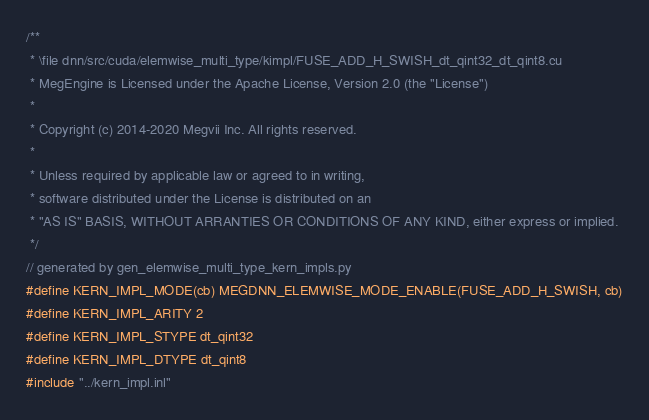<code> <loc_0><loc_0><loc_500><loc_500><_Cuda_>/**
 * \file dnn/src/cuda/elemwise_multi_type/kimpl/FUSE_ADD_H_SWISH_dt_qint32_dt_qint8.cu
 * MegEngine is Licensed under the Apache License, Version 2.0 (the "License")
 *
 * Copyright (c) 2014-2020 Megvii Inc. All rights reserved.
 *
 * Unless required by applicable law or agreed to in writing,
 * software distributed under the License is distributed on an
 * "AS IS" BASIS, WITHOUT ARRANTIES OR CONDITIONS OF ANY KIND, either express or implied.
 */
// generated by gen_elemwise_multi_type_kern_impls.py
#define KERN_IMPL_MODE(cb) MEGDNN_ELEMWISE_MODE_ENABLE(FUSE_ADD_H_SWISH, cb)
#define KERN_IMPL_ARITY 2
#define KERN_IMPL_STYPE dt_qint32
#define KERN_IMPL_DTYPE dt_qint8
#include "../kern_impl.inl"
</code> 